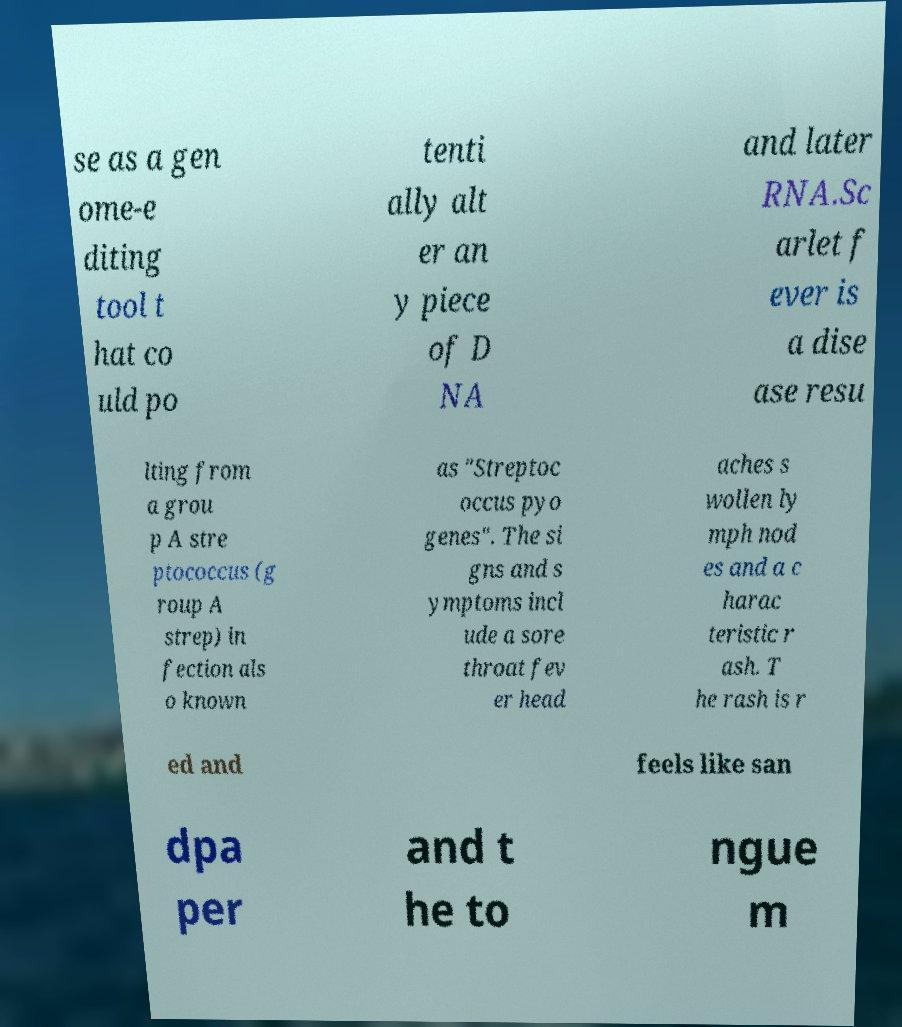Can you read and provide the text displayed in the image?This photo seems to have some interesting text. Can you extract and type it out for me? se as a gen ome-e diting tool t hat co uld po tenti ally alt er an y piece of D NA and later RNA.Sc arlet f ever is a dise ase resu lting from a grou p A stre ptococcus (g roup A strep) in fection als o known as "Streptoc occus pyo genes". The si gns and s ymptoms incl ude a sore throat fev er head aches s wollen ly mph nod es and a c harac teristic r ash. T he rash is r ed and feels like san dpa per and t he to ngue m 